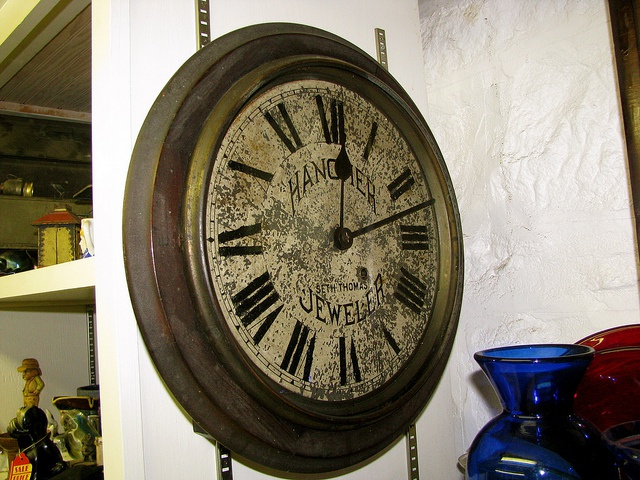Describe the objects in this image and their specific colors. I can see clock in tan, black, olive, and gray tones and vase in tan, black, navy, darkblue, and blue tones in this image. 